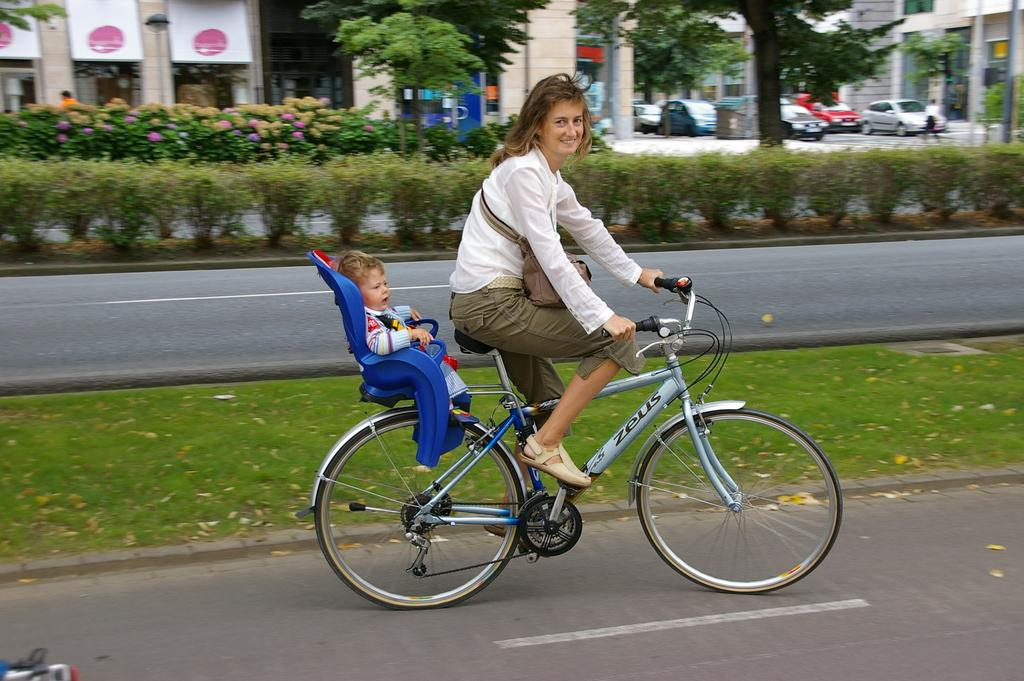Who is present in the image? There is a woman and a baby in the image. What are they doing in the image? The woman and baby are sitting on a cycle. Where are they located in the image? They are on a path. What can be seen in the background of the image? There is grass, plants, cars, buildings, and trees in the background of the image. What type of stocking is the woman wearing in the image? There is no information about the woman's stockings in the image. Can you tell me where the river is located in the image? There is no river present in the image. Is there a church visible in the background of the image? There is no church present in the image. 